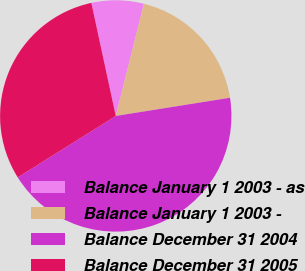Convert chart. <chart><loc_0><loc_0><loc_500><loc_500><pie_chart><fcel>Balance January 1 2003 - as<fcel>Balance January 1 2003 -<fcel>Balance December 31 2004<fcel>Balance December 31 2005<nl><fcel>7.3%<fcel>18.57%<fcel>43.61%<fcel>30.52%<nl></chart> 